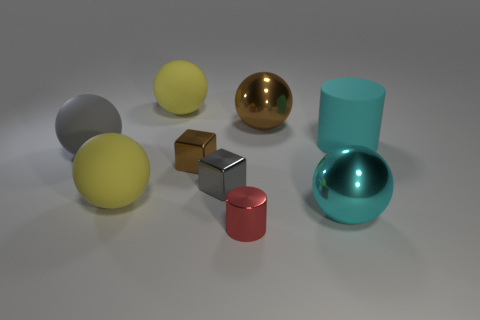Subtract all yellow spheres. How many were subtracted if there are1yellow spheres left? 1 Subtract all brown metallic spheres. How many spheres are left? 4 Subtract all blue cubes. How many blue cylinders are left? 0 Subtract all big yellow spheres. Subtract all gray metal things. How many objects are left? 6 Add 9 tiny gray objects. How many tiny gray objects are left? 10 Add 1 large cyan balls. How many large cyan balls exist? 2 Add 1 large yellow rubber things. How many objects exist? 10 Subtract all brown spheres. How many spheres are left? 4 Subtract 1 gray spheres. How many objects are left? 8 Subtract all balls. How many objects are left? 4 